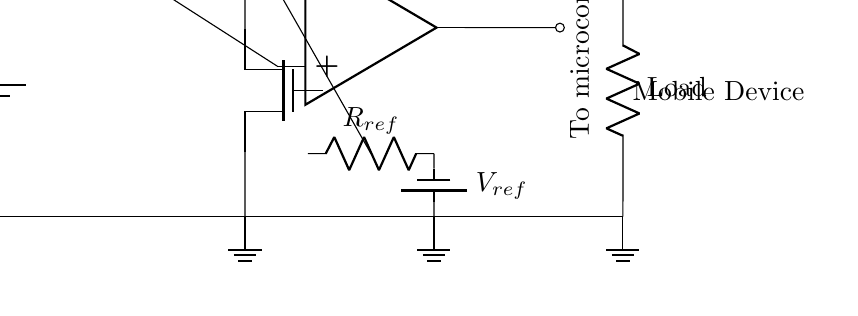What is the purpose of the current sense resistor? The current sense resistor is used to measure the current flowing through the circuit. When current passes through it, it generates a voltage proportional to the current, which is used by the comparator to assess if the current exceeds a predefined limit.
Answer: Measure current What type of MOSFET is used in this circuit? The circuit uses an N-channel MOSFET, as indicated by "Tnmos" label, which is generally used for switching applications, especially in low-side switching configurations.
Answer: N-channel What voltage does the reference voltage battery provide? The reference voltage battery is labeled Vref, and it provides the reference voltage for the comparator to determine the threshold for the overcurrent condition.
Answer: Vref How many ground connections are visible in the circuit? There are three ground connections visible in the circuit, corresponding to the power source, reference voltage, and load, all grounded to a common point.
Answer: Three What is the output of the op-amp connected to? The output of the op-amp is connected to a microcontroller, which will use the output to determine if an overcurrent condition has been detected and potentially trigger a shutdown.
Answer: Microcontroller How is the comparator connected in this circuit? The comparator is connected to the current sense resistor at its non-inverting terminal and to the reference resistor at its inverting terminal, facilitating a voltage comparison to detect an overcurrent condition.
Answer: Voltage comparison What component inhibits current flow during an overcurrent condition? The MOSFET inhibits current flow during an overcurrent condition when the comparator detects that the current exceeds the reference threshold, thus controlling the load's operation.
Answer: MOSFET 